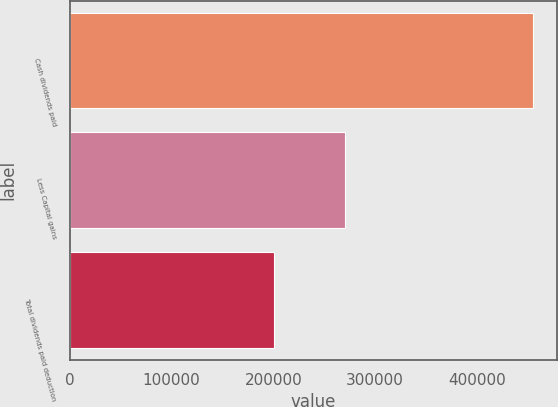<chart> <loc_0><loc_0><loc_500><loc_500><bar_chart><fcel>Cash dividends paid<fcel>Less Capital gains<fcel>Total dividends paid deduction<nl><fcel>455606<fcel>270854<fcel>200960<nl></chart> 